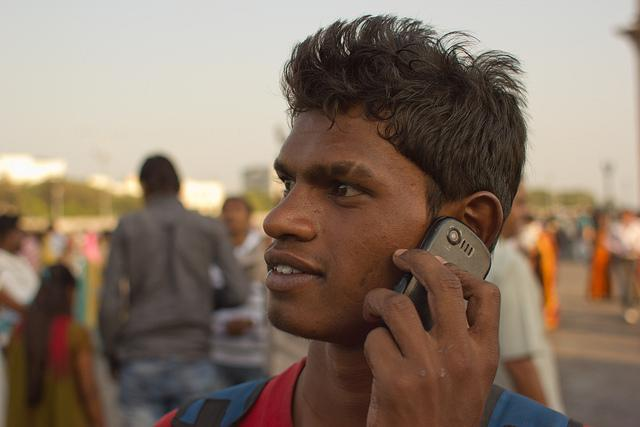What is a famous company that makes the device the man is holding? Please explain your reasoning. samsung. The brand is unclear but based on the device being a cellphone of this type and the other options, answer a seems most likely. 